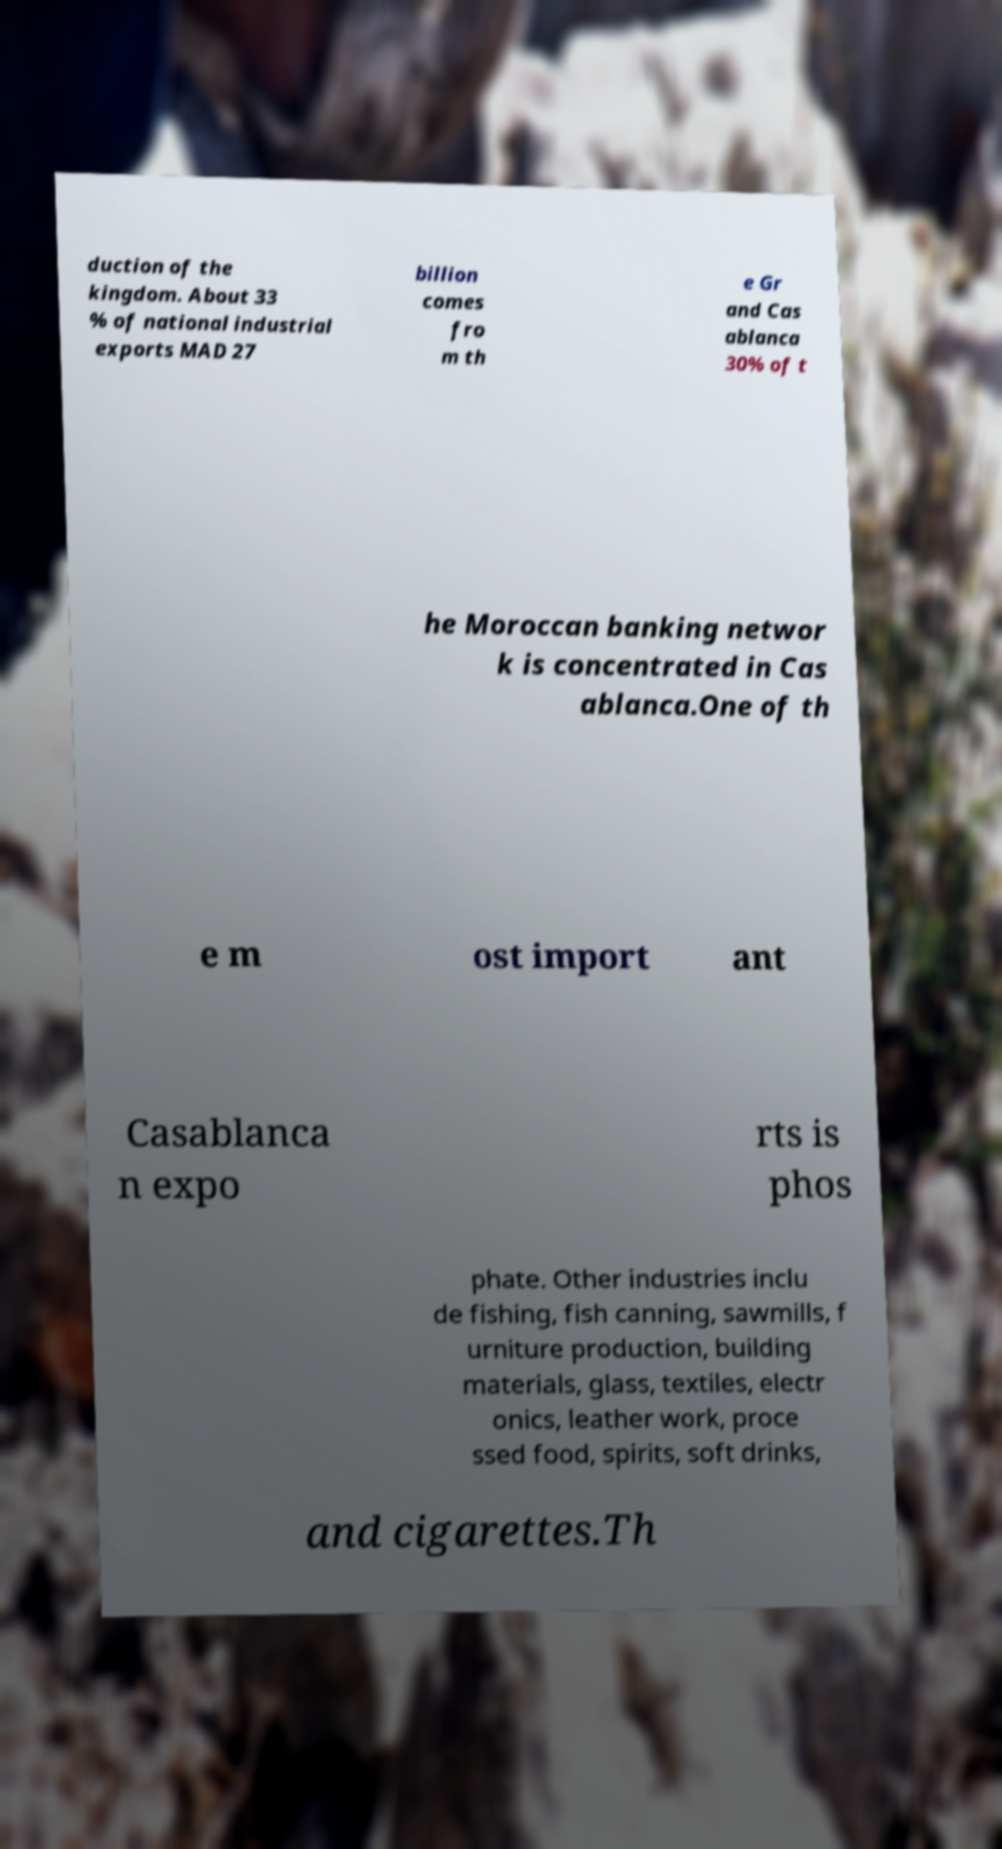Please read and relay the text visible in this image. What does it say? duction of the kingdom. About 33 % of national industrial exports MAD 27 billion comes fro m th e Gr and Cas ablanca 30% of t he Moroccan banking networ k is concentrated in Cas ablanca.One of th e m ost import ant Casablanca n expo rts is phos phate. Other industries inclu de fishing, fish canning, sawmills, f urniture production, building materials, glass, textiles, electr onics, leather work, proce ssed food, spirits, soft drinks, and cigarettes.Th 